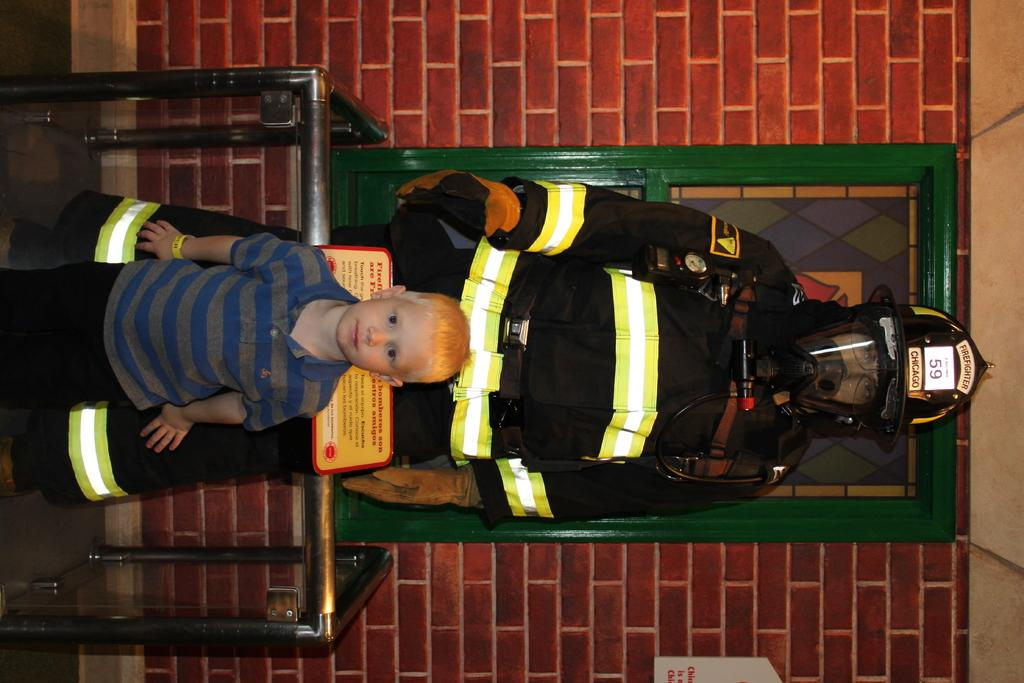What is the orientation of the image? The image appears to be rotated. How many people are in the image? There are two people standing in the image. What can be seen in the background of the image? There is a wall with red bricks in the background of the image. What type of dress are the dolls wearing in the image? There are no dolls present in the image, so it is not possible to answer that question. 